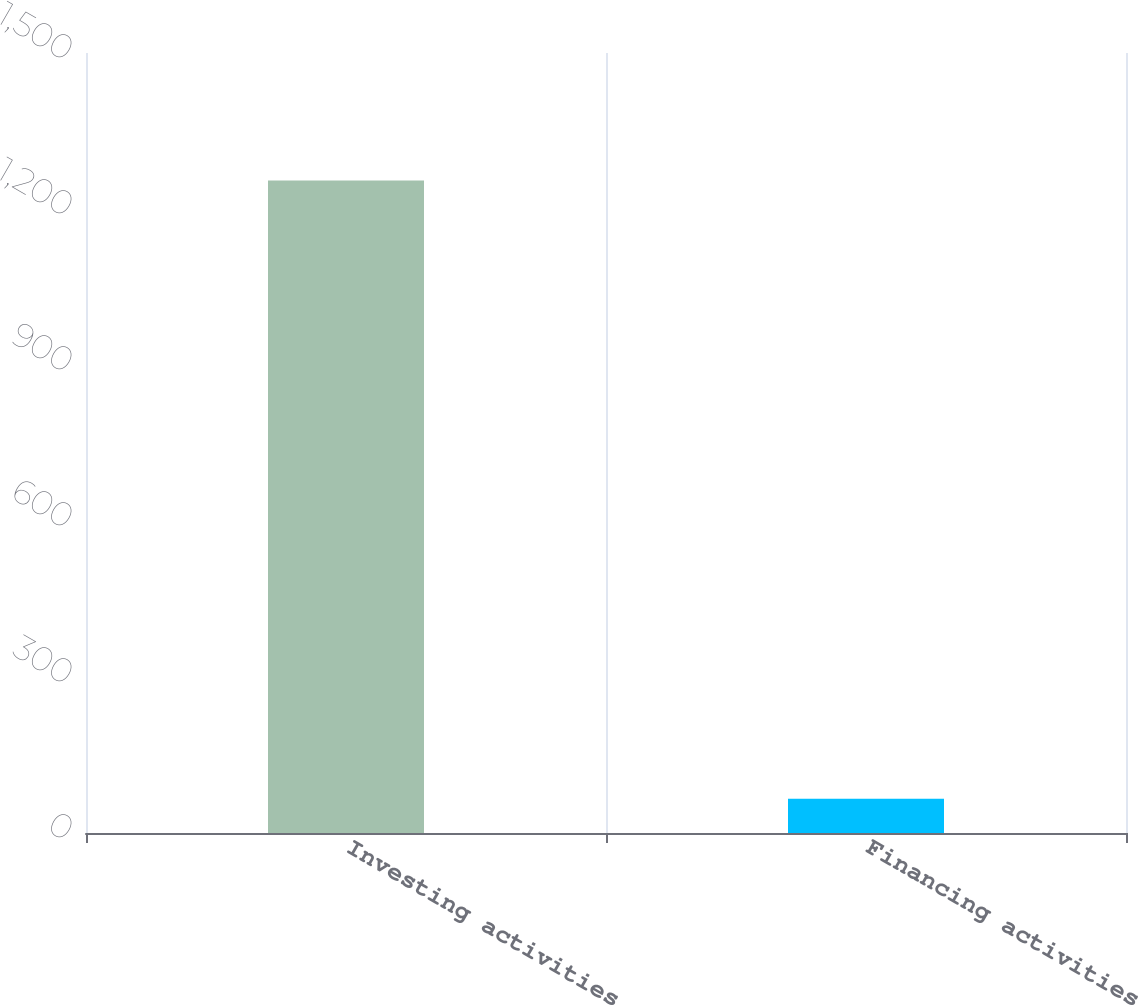Convert chart. <chart><loc_0><loc_0><loc_500><loc_500><bar_chart><fcel>Investing activities<fcel>Financing activities<nl><fcel>1255<fcel>66<nl></chart> 